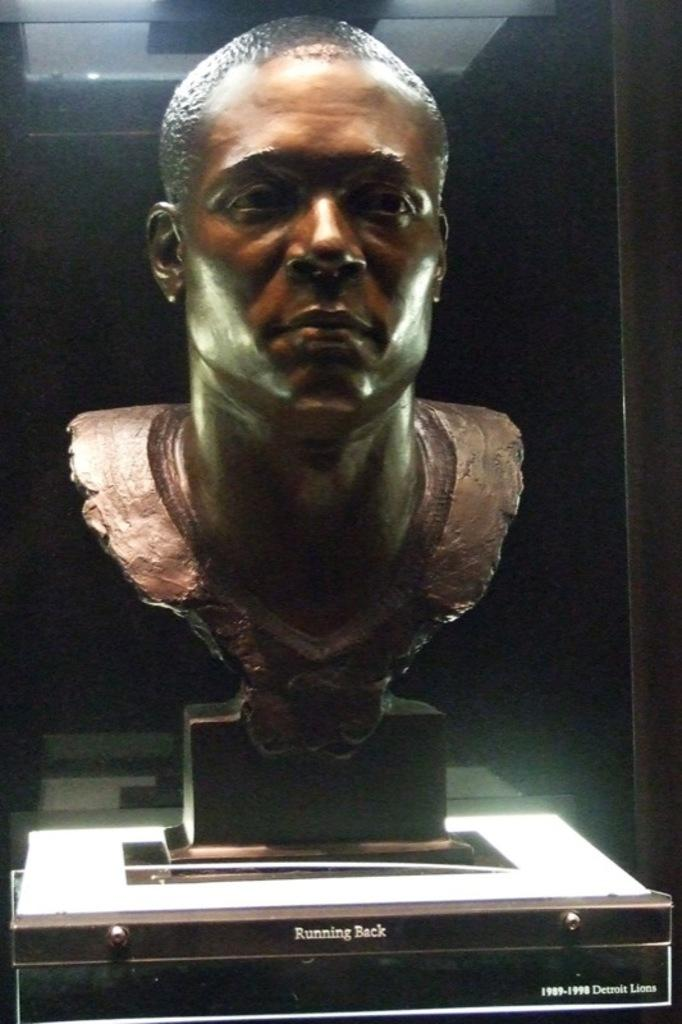What is the main subject of the image? The main subject of the image is a sculpture. How is the sculpture displayed in the image? The sculpture is placed in a glass box. What type of lace is used to create the sculpture in the image? There is no lace present in the image; the sculpture is made of a different material. 